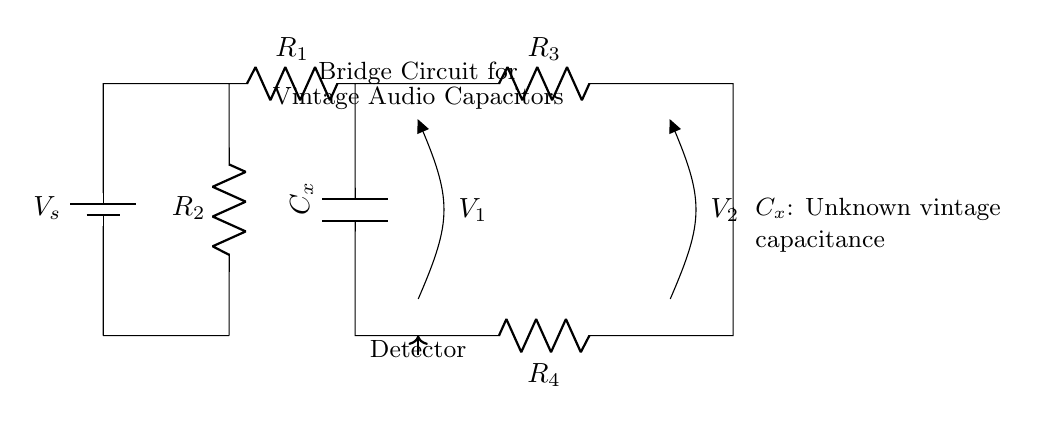What is the voltage source labeled in the circuit? The voltage source is labeled as V_s, indicating the applied voltage across the circuit.
Answer: V_s What is the value of the resistor R_1? The circuit diagram does not provide a specific numerical value for R_1, thus it remains unspecified.
Answer: unspecified Which component represents the unknown vintage capacitance? The component labeled with C_x is indicated to be the unknown vintage capacitance to be measured.
Answer: C_x How many resistors are present in this circuit? There are four resistors labeled R_1, R_2, R_3, and R_4, denoting the total count of resistive components in the circuit.
Answer: 4 What is the purpose of the detector in the circuit? The detector's purpose is to measure the voltage differences V_1 and V_2 across the open terminals, providing information about the balance in the bridge circuit.
Answer: Measure voltage differences Why is it important to balance a bridge circuit? Balancing the bridge circuit ensures that the voltage across the detectors is zero, which indicates the capacitance can be determined accurately without interference from other factors.
Answer: Ensures accurate measurement 